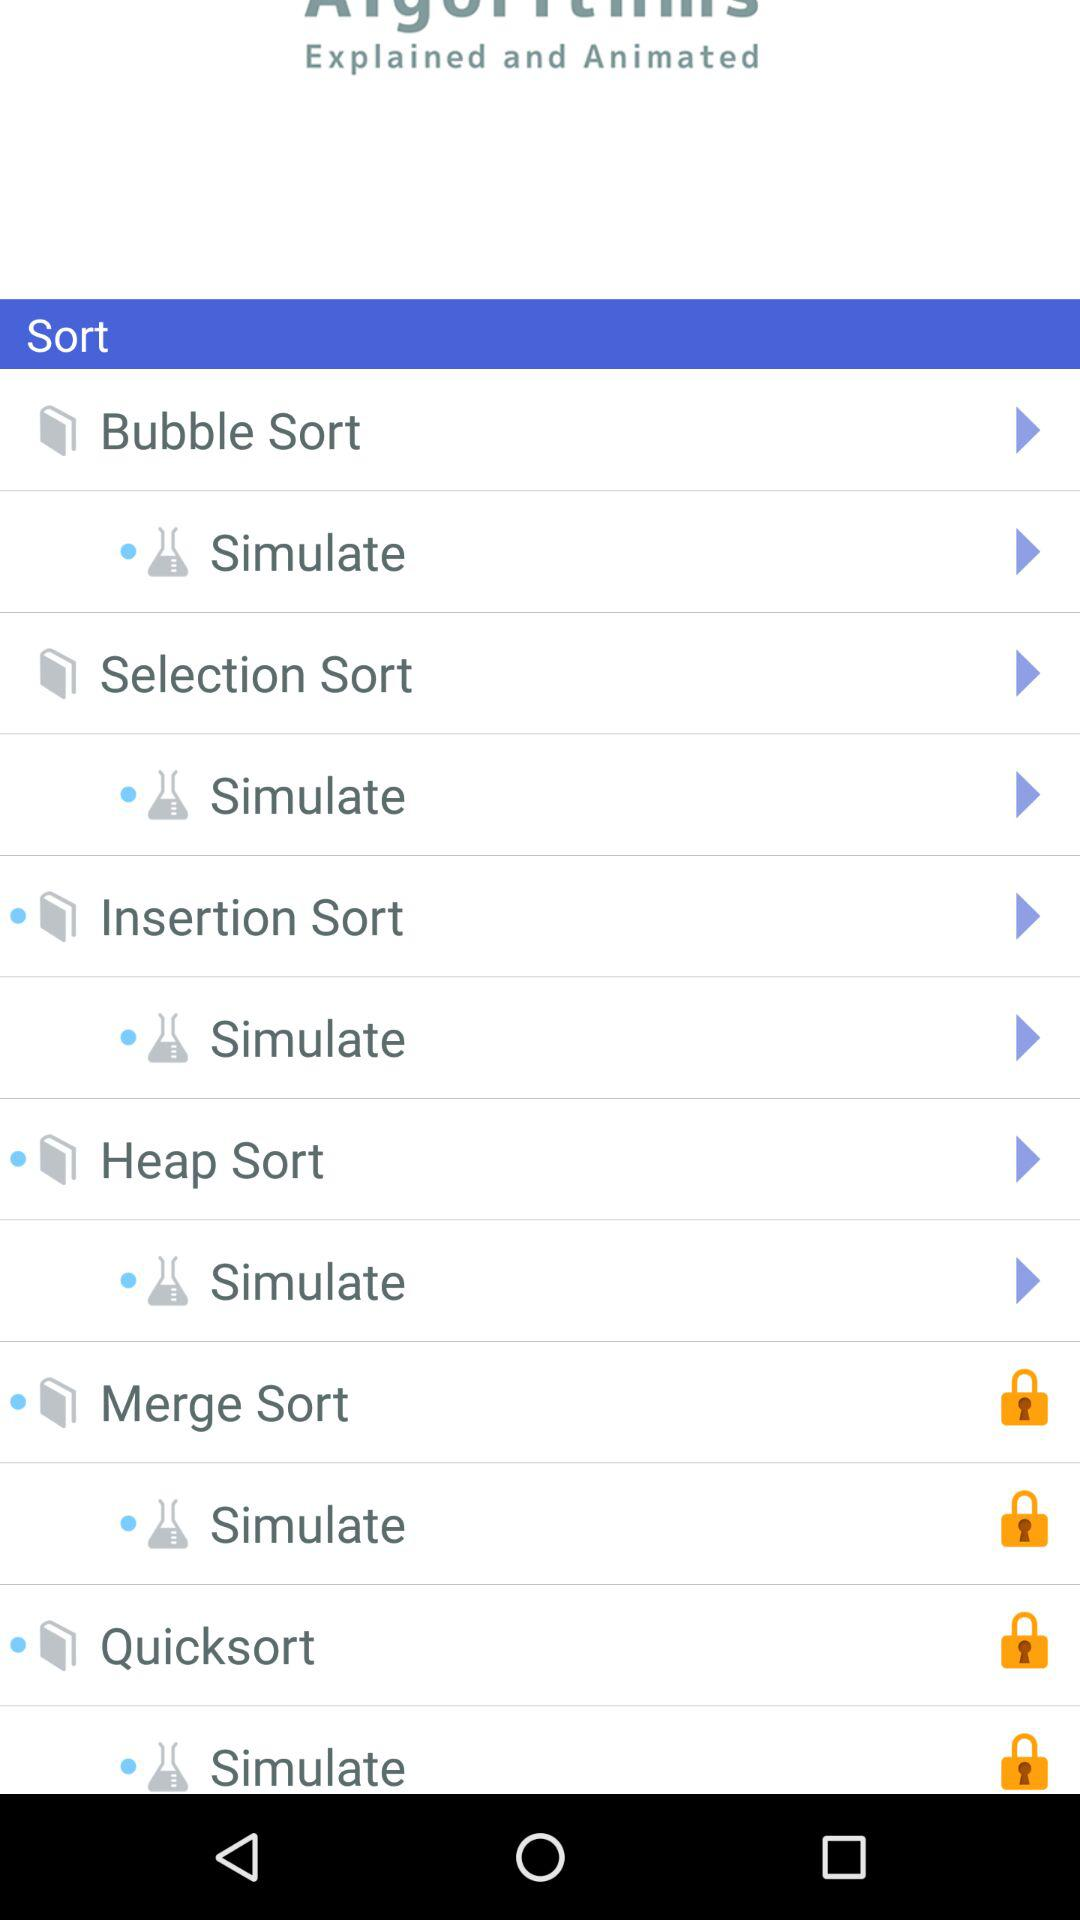Which are the different sorts? The different sorts are "Bubble Sort", "Selection Sort", "Insertion Sort", "Heap Sort", "Merge Sort" and "Quicksort". 